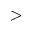<formula> <loc_0><loc_0><loc_500><loc_500>></formula> 